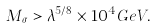<formula> <loc_0><loc_0><loc_500><loc_500>M _ { \sigma } > \lambda ^ { 5 / 8 } \times 1 0 ^ { 4 } G e V .</formula> 